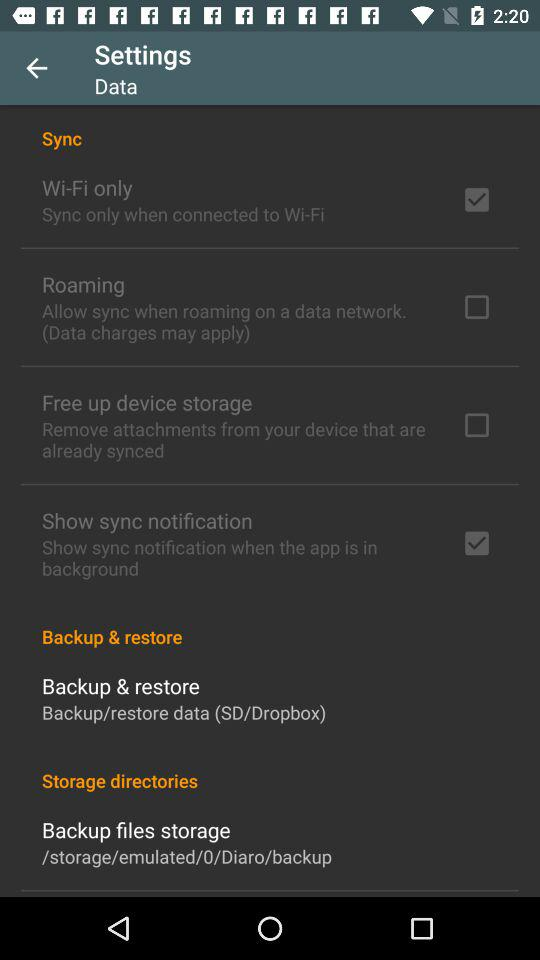Which options are selected? The selected options are "Wi-Fi only" and "Show sync notification". 